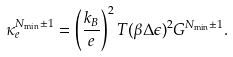<formula> <loc_0><loc_0><loc_500><loc_500>\kappa _ { e } ^ { N _ { \min } \pm 1 } = \left ( \frac { k _ { B } } { e } \right ) ^ { 2 } T ( \beta \Delta \epsilon ) ^ { 2 } G ^ { N _ { \min } \pm 1 } .</formula> 